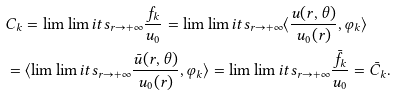Convert formula to latex. <formula><loc_0><loc_0><loc_500><loc_500>& C _ { k } = \lim \lim i t s _ { r \to + \infty } \frac { f _ { k } } { u _ { 0 } } = \lim \lim i t s _ { r \to + \infty } \langle \frac { u ( r , \theta ) } { u _ { 0 } ( r ) } , \varphi _ { k } \rangle \\ & = \langle \lim \lim i t s _ { r \to + \infty } \frac { \bar { u } ( r , \theta ) } { u _ { 0 } ( r ) } , \varphi _ { k } \rangle = \lim \lim i t s _ { r \to + \infty } \frac { \bar { f } _ { k } } { u _ { 0 } } = \bar { C } _ { k } .</formula> 